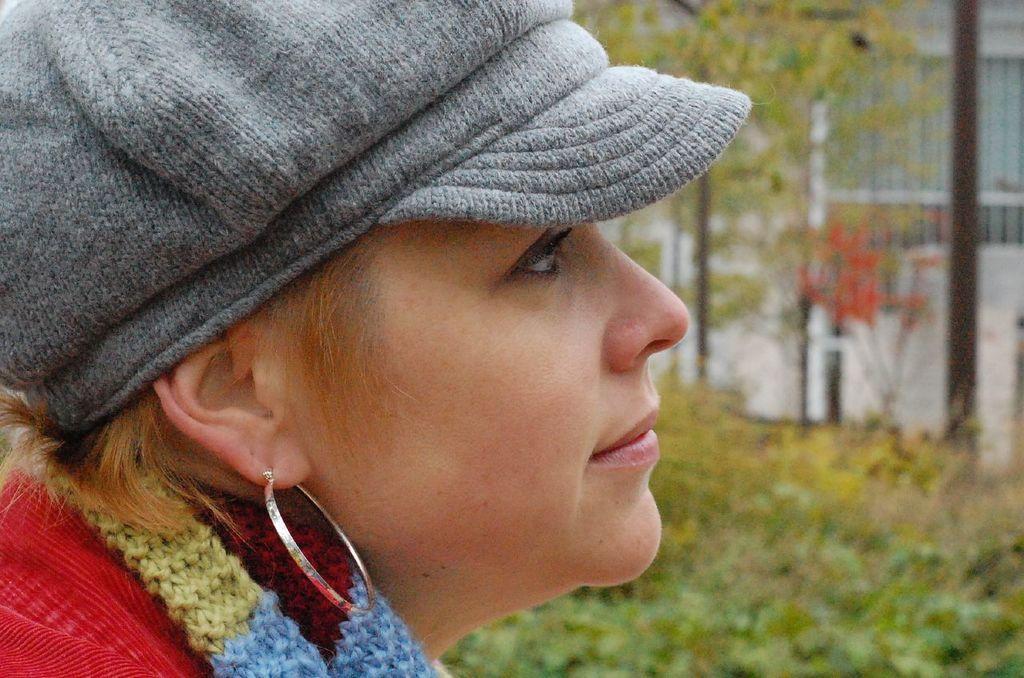In one or two sentences, can you explain what this image depicts? In this image I can see the person is wearing ash color cap and the colorful dress. I can see few trees and the blurred background. 